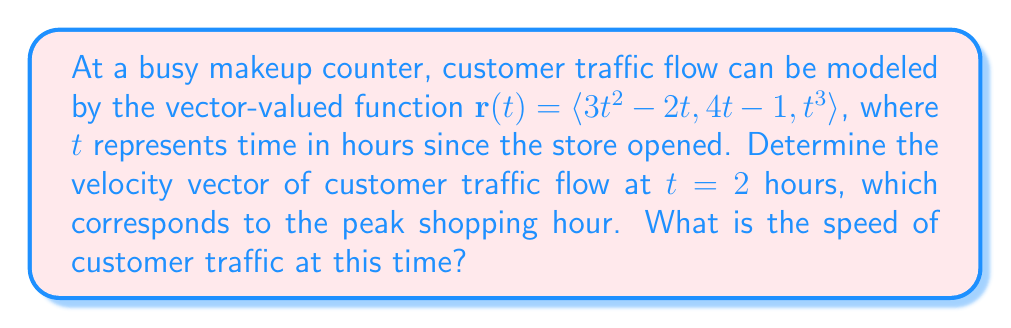Show me your answer to this math problem. To solve this problem, we need to follow these steps:

1) The velocity vector is given by the first derivative of the position vector $\mathbf{r}(t)$. So, we need to calculate $\mathbf{v}(t) = \mathbf{r}'(t)$.

2) Let's differentiate each component of $\mathbf{r}(t)$:
   
   $\frac{d}{dt}(3t^2 - 2t) = 6t - 2$
   $\frac{d}{dt}(4t - 1) = 4$
   $\frac{d}{dt}(t^3) = 3t^2$

3) Therefore, the velocity vector is:
   
   $\mathbf{v}(t) = \langle 6t - 2, 4, 3t^2 \rangle$

4) To find the velocity at $t = 2$, we substitute $t = 2$ into $\mathbf{v}(t)$:
   
   $\mathbf{v}(2) = \langle 6(2) - 2, 4, 3(2)^2 \rangle = \langle 10, 4, 12 \rangle$

5) The speed is the magnitude of the velocity vector. We can calculate this using the formula:
   
   $\text{speed} = \|\mathbf{v}(2)\| = \sqrt{(10)^2 + (4)^2 + (12)^2}$

6) Simplifying:
   
   $\text{speed} = \sqrt{100 + 16 + 144} = \sqrt{260} \approx 16.12$
Answer: The velocity vector of customer traffic flow at $t = 2$ hours is $\mathbf{v}(2) = \langle 10, 4, 12 \rangle$, and the speed of customer traffic at this time is $\sqrt{260} \approx 16.12$ units per hour. 